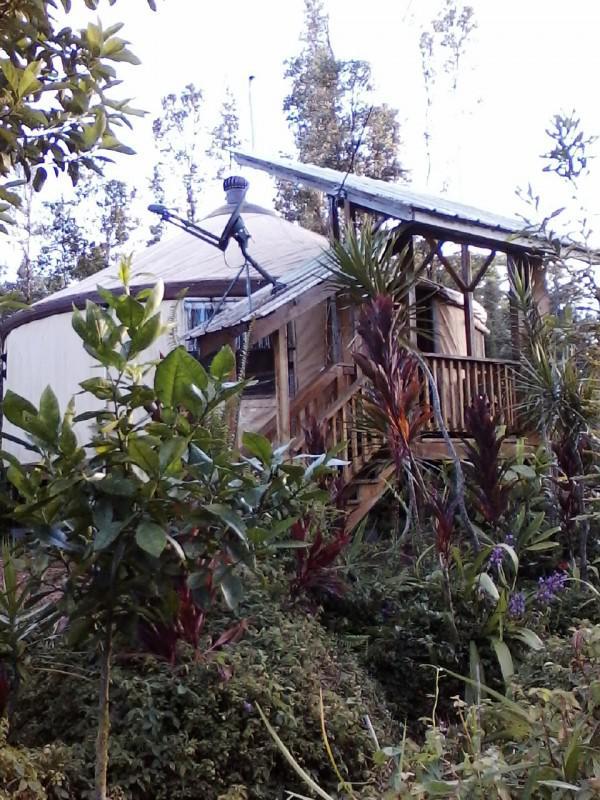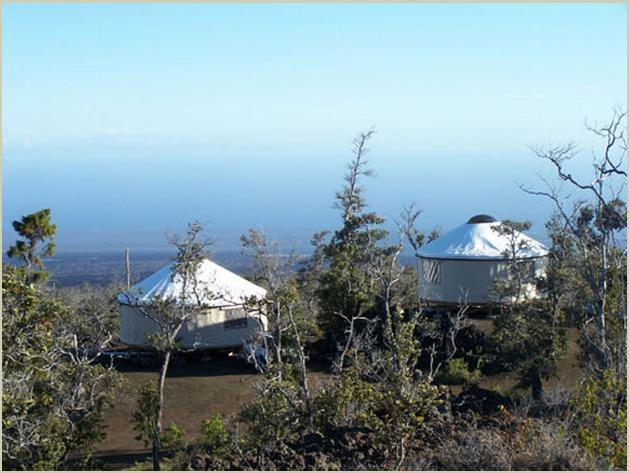The first image is the image on the left, the second image is the image on the right. For the images shown, is this caption "Two round houses with white roofs and walls are in one image." true? Answer yes or no. Yes. The first image is the image on the left, the second image is the image on the right. Assess this claim about the two images: "There are four or more yurts in the left image and some of them are red.". Correct or not? Answer yes or no. No. 